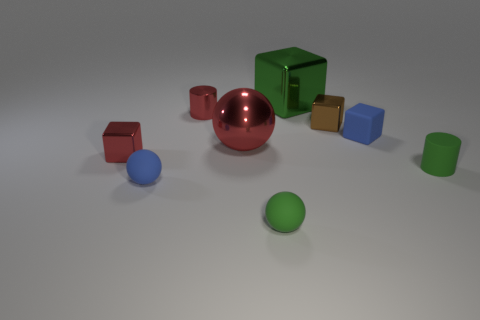Subtract all small red shiny cubes. How many cubes are left? 3 Subtract 3 balls. How many balls are left? 0 Subtract all blue cubes. How many red cylinders are left? 1 Subtract all large red metal cylinders. Subtract all blue things. How many objects are left? 7 Add 5 red cylinders. How many red cylinders are left? 6 Add 7 metal spheres. How many metal spheres exist? 8 Subtract all blue spheres. How many spheres are left? 2 Subtract 1 red balls. How many objects are left? 8 Subtract all balls. How many objects are left? 6 Subtract all red blocks. Subtract all purple cylinders. How many blocks are left? 3 